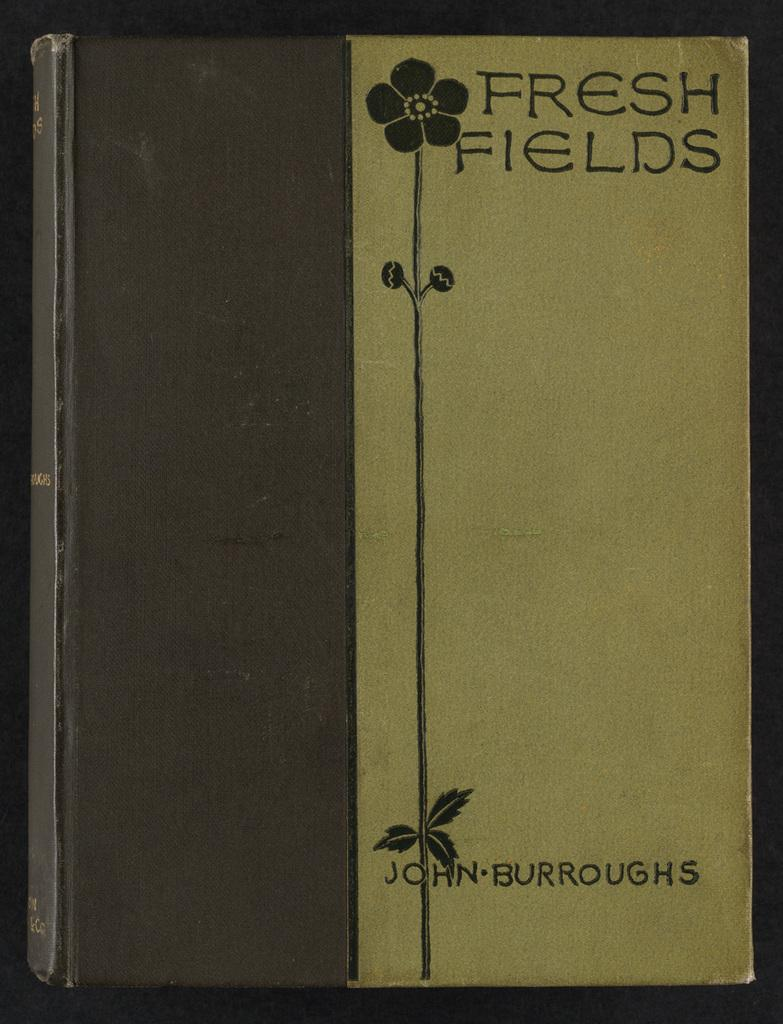<image>
Create a compact narrative representing the image presented. A brown book with a flower on it called Fresh Fields. 